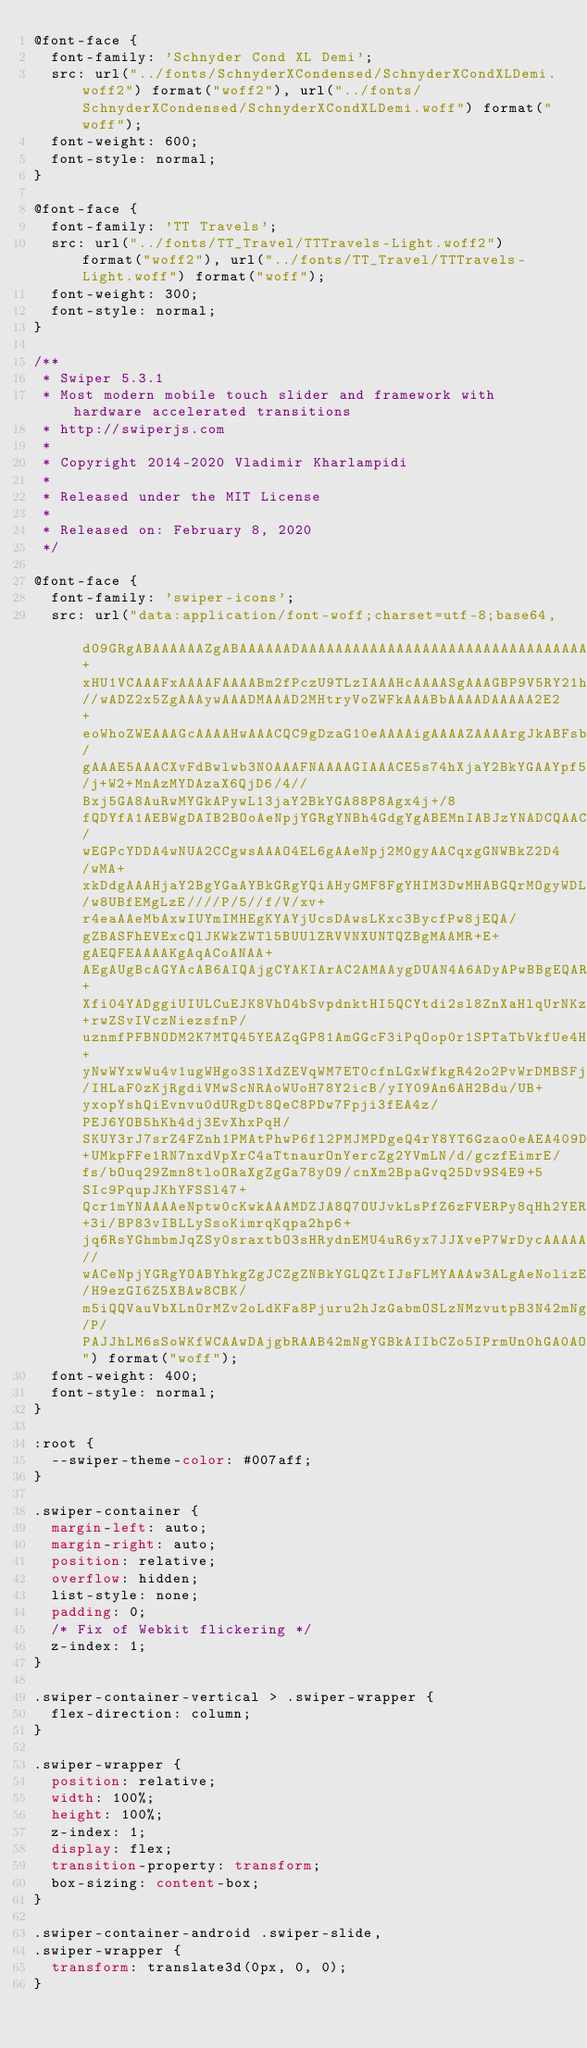<code> <loc_0><loc_0><loc_500><loc_500><_CSS_>@font-face {
  font-family: 'Schnyder Cond XL Demi';
  src: url("../fonts/SchnyderXCondensed/SchnyderXCondXLDemi.woff2") format("woff2"), url("../fonts/SchnyderXCondensed/SchnyderXCondXLDemi.woff") format("woff");
  font-weight: 600;
  font-style: normal;
}

@font-face {
  font-family: 'TT Travels';
  src: url("../fonts/TT_Travel/TTTravels-Light.woff2") format("woff2"), url("../fonts/TT_Travel/TTTravels-Light.woff") format("woff");
  font-weight: 300;
  font-style: normal;
}

/**
 * Swiper 5.3.1
 * Most modern mobile touch slider and framework with hardware accelerated transitions
 * http://swiperjs.com
 *
 * Copyright 2014-2020 Vladimir Kharlampidi
 *
 * Released under the MIT License
 *
 * Released on: February 8, 2020
 */

@font-face {
  font-family: 'swiper-icons';
  src: url("data:application/font-woff;charset=utf-8;base64, d09GRgABAAAAAAZgABAAAAAADAAAAAAAAAAAAAAAAAAAAAAAAAAAAAAAAABGRlRNAAAGRAAAABoAAAAci6qHkUdERUYAAAWgAAAAIwAAACQAYABXR1BPUwAABhQAAAAuAAAANuAY7+xHU1VCAAAFxAAAAFAAAABm2fPczU9TLzIAAAHcAAAASgAAAGBP9V5RY21hcAAAAkQAAACIAAABYt6F0cBjdnQgAAACzAAAAAQAAAAEABEBRGdhc3AAAAWYAAAACAAAAAj//wADZ2x5ZgAAAywAAADMAAAD2MHtryVoZWFkAAABbAAAADAAAAA2E2+eoWhoZWEAAAGcAAAAHwAAACQC9gDzaG10eAAAAigAAAAZAAAArgJkABFsb2NhAAAC0AAAAFoAAABaFQAUGG1heHAAAAG8AAAAHwAAACAAcABAbmFtZQAAA/gAAAE5AAACXvFdBwlwb3N0AAAFNAAAAGIAAACE5s74hXjaY2BkYGAAYpf5Hu/j+W2+MnAzMYDAzaX6QjD6/4//Bxj5GA8AuRwMYGkAPywL13jaY2BkYGA88P8Agx4j+/8fQDYfA1AEBWgDAIB2BOoAeNpjYGRgYNBh4GdgYgABEMnIABJzYNADCQAACWgAsQB42mNgYfzCOIGBlYGB0YcxjYGBwR1Kf2WQZGhhYGBiYGVmgAFGBiQQkOaawtDAoMBQxXjg/wEGPcYDDA4wNUA2CCgwsAAAO4EL6gAAeNpj2M0gyAACqxgGNWBkZ2D4/wMA+xkDdgAAAHjaY2BgYGaAYBkGRgYQiAHyGMF8FgYHIM3DwMHABGQrMOgyWDLEM1T9/w8UBfEMgLzE////P/5//f/V/xv+r4eaAAeMbAxwIUYmIMHEgKYAYjUcsDAwsLKxc3BycfPw8jEQA/gZBASFhEVExcQlJKWkZWTl5BUUlZRVVNXUNTQZBgMAAMR+E+gAEQFEAAAAKgAqACoANAA+AEgAUgBcAGYAcAB6AIQAjgCYAKIArAC2AMAAygDUAN4A6ADyAPwBBgEQARoBJAEuATgBQgFMAVYBYAFqAXQBfgGIAZIBnAGmAbIBzgHsAAB42u2NMQ6CUAyGW568x9AneYYgm4MJbhKFaExIOAVX8ApewSt4Bic4AfeAid3VOBixDxfPYEza5O+Xfi04YADggiUIULCuEJK8VhO4bSvpdnktHI5QCYtdi2sl8ZnXaHlqUrNKzdKcT8cjlq+rwZSvIVczNiezsfnP/uznmfPFBNODM2K7MTQ45YEAZqGP81AmGGcF3iPqOop0r1SPTaTbVkfUe4HXj97wYE+yNwWYxwWu4v1ugWHgo3S1XdZEVqWM7ET0cfnLGxWfkgR42o2PvWrDMBSFj/IHLaF0zKjRgdiVMwScNRAoWUoH78Y2icB/yIY09An6AH2Bdu/UB+yxopYshQiEvnvu0dURgDt8QeC8PDw7Fpji3fEA4z/PEJ6YOB5hKh4dj3EvXhxPqH/SKUY3rJ7srZ4FZnh1PMAtPhwP6fl2PMJMPDgeQ4rY8YT6Gzao0eAEA409DuggmTnFnOcSCiEiLMgxCiTI6Cq5DZUd3Qmp10vO0LaLTd2cjN4fOumlc7lUYbSQcZFkutRG7g6JKZKy0RmdLY680CDnEJ+UMkpFFe1RN7nxdVpXrC4aTtnaurOnYercZg2YVmLN/d/gczfEimrE/fs/bOuq29Zmn8tloORaXgZgGa78yO9/cnXm2BpaGvq25Dv9S4E9+5SIc9PqupJKhYFSSl47+Qcr1mYNAAAAeNptw0cKwkAAAMDZJA8Q7OUJvkLsPfZ6zFVERPy8qHh2YER+3i/BP83vIBLLySsoKimrqKqpa2hp6+jq6RsYGhmbmJqZSy0sraxtbO3sHRydnEMU4uR6yx7JJXveP7WrDycAAAAAAAH//wACeNpjYGRgYOABYhkgZgJCZgZNBkYGLQZtIJsFLMYAAAw3ALgAeNolizEKgDAQBCchRbC2sFER0YD6qVQiBCv/H9ezGI6Z5XBAw8CBK/m5iQQVauVbXLnOrMZv2oLdKFa8Pjuru2hJzGabmOSLzNMzvutpB3N42mNgZGBg4GKQYzBhYMxJLMlj4GBgAYow/P/PAJJhLM6sSoWKfWCAAwDAjgbRAAB42mNgYGBkAIIbCZo5IPrmUn0hGA0AO8EFTQAA") format("woff");
  font-weight: 400;
  font-style: normal;
}

:root {
  --swiper-theme-color: #007aff;
}

.swiper-container {
  margin-left: auto;
  margin-right: auto;
  position: relative;
  overflow: hidden;
  list-style: none;
  padding: 0;
  /* Fix of Webkit flickering */
  z-index: 1;
}

.swiper-container-vertical > .swiper-wrapper {
  flex-direction: column;
}

.swiper-wrapper {
  position: relative;
  width: 100%;
  height: 100%;
  z-index: 1;
  display: flex;
  transition-property: transform;
  box-sizing: content-box;
}

.swiper-container-android .swiper-slide,
.swiper-wrapper {
  transform: translate3d(0px, 0, 0);
}
</code> 